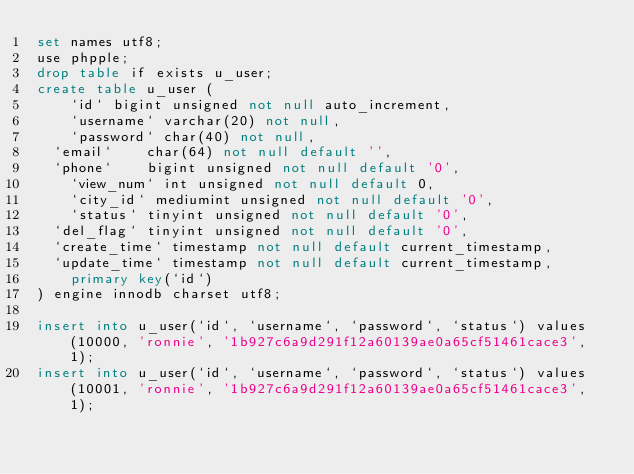<code> <loc_0><loc_0><loc_500><loc_500><_SQL_>set names utf8;
use phpple;
drop table if exists u_user;
create table u_user (
    `id` bigint unsigned not null auto_increment,
    `username` varchar(20) not null,
    `password` char(40) not null,
	`email`    char(64) not null default '',
	`phone`    bigint unsigned not null default '0',
    `view_num` int unsigned not null default 0,
    `city_id` mediumint unsigned not null default '0',
   	`status` tinyint unsigned not null default '0',
	`del_flag` tinyint unsigned not null default '0',
	`create_time` timestamp not null default current_timestamp,
	`update_time` timestamp not null default current_timestamp,
    primary key(`id`)
) engine innodb charset utf8;

insert into u_user(`id`, `username`, `password`, `status`) values(10000, 'ronnie', '1b927c6a9d291f12a60139ae0a65cf51461cace3', 1);
insert into u_user(`id`, `username`, `password`, `status`) values(10001, 'ronnie', '1b927c6a9d291f12a60139ae0a65cf51461cace3', 1);
</code> 